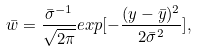Convert formula to latex. <formula><loc_0><loc_0><loc_500><loc_500>\bar { w } = \frac { \bar { \sigma } ^ { - 1 } } { \sqrt { 2 \pi } } e x p [ - \frac { ( y - \bar { y } ) ^ { 2 } } { 2 \bar { \sigma } ^ { 2 } } ] ,</formula> 